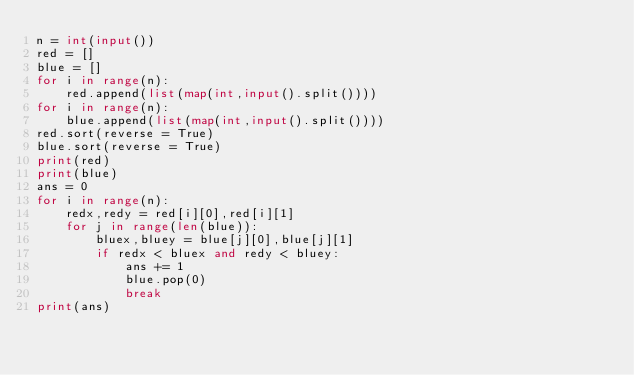Convert code to text. <code><loc_0><loc_0><loc_500><loc_500><_Python_>n = int(input())
red = []
blue = []
for i in range(n):
    red.append(list(map(int,input().split())))
for i in range(n):
    blue.append(list(map(int,input().split())))
red.sort(reverse = True)
blue.sort(reverse = True)
print(red)
print(blue)
ans = 0
for i in range(n):
    redx,redy = red[i][0],red[i][1]
    for j in range(len(blue)):
        bluex,bluey = blue[j][0],blue[j][1]
        if redx < bluex and redy < bluey:
            ans += 1
            blue.pop(0)
            break
print(ans)</code> 